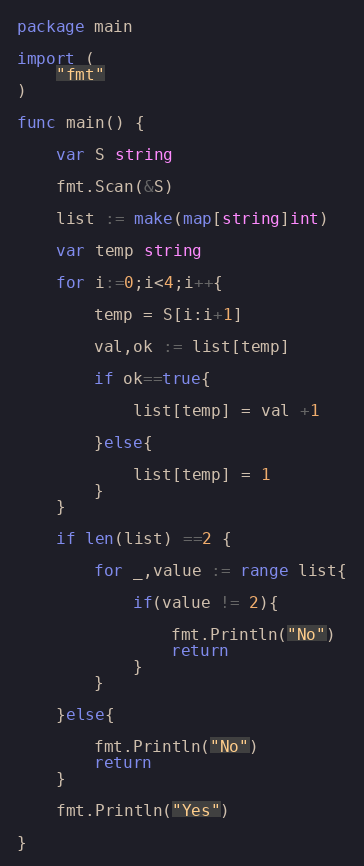<code> <loc_0><loc_0><loc_500><loc_500><_Go_>package main

import (
	"fmt"
)

func main() {

	var S string

	fmt.Scan(&S)

	list := make(map[string]int)

	var temp string

	for i:=0;i<4;i++{

		temp = S[i:i+1]

		val,ok := list[temp]

		if ok==true{

			list[temp] = val +1

		}else{

			list[temp] = 1
		}
	}

	if len(list) ==2 {

		for _,value := range list{

			if(value != 2){

				fmt.Println("No")
				return
			}
		}

	}else{

		fmt.Println("No")
		return
	}

	fmt.Println("Yes")

}</code> 